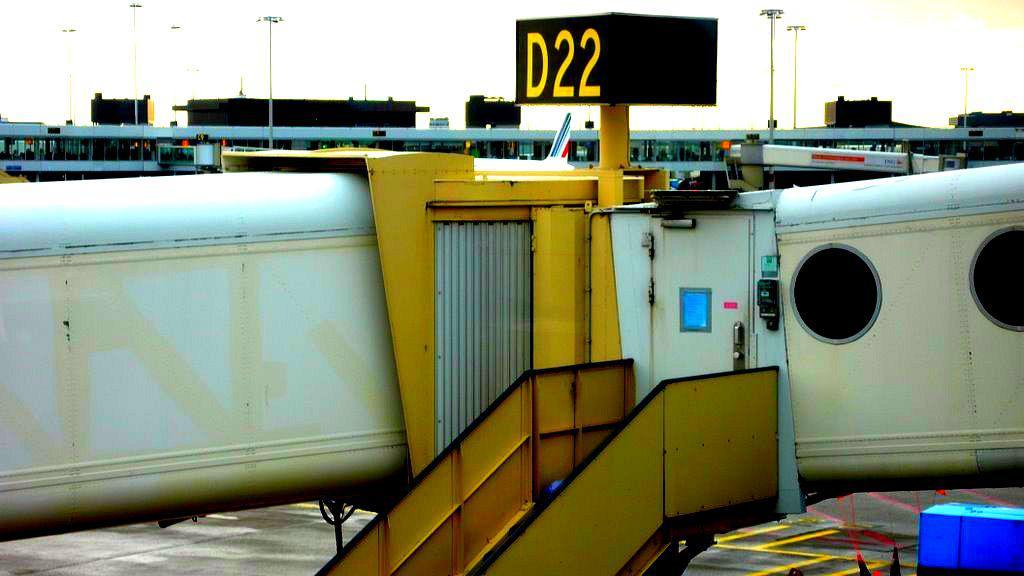Provide a one-sentence caption for the provided image. An aircraft boarding ramp is connected to terminal D22. 